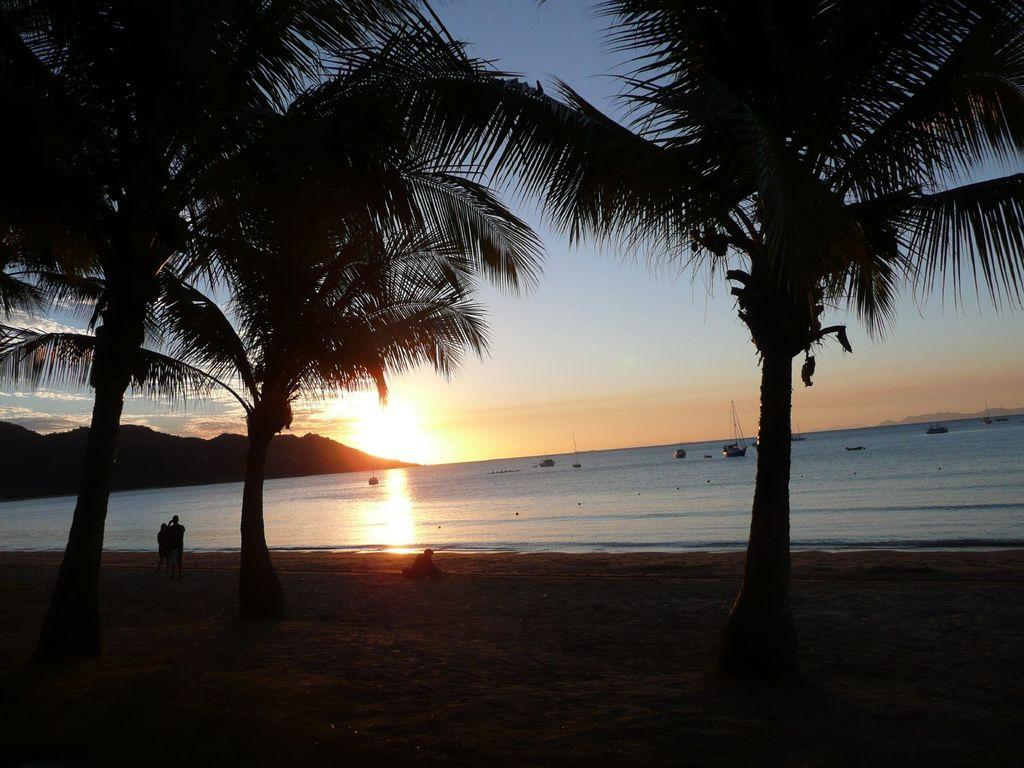How many persons can be seen in the image? There are persons in the image, but the exact number is not specified. What is located on the water in the image? There are boats on the water in the image. What type of vegetation is visible in the image? Trees are visible in the image. What type of landform can be seen in the image? There is a mountain in the image. What part of the natural environment is visible in the image? The sky is visible in the image. What type of substance is being attempted to be created by the persons in the image? There is no indication in the image that the persons are attempting to create any substance. 